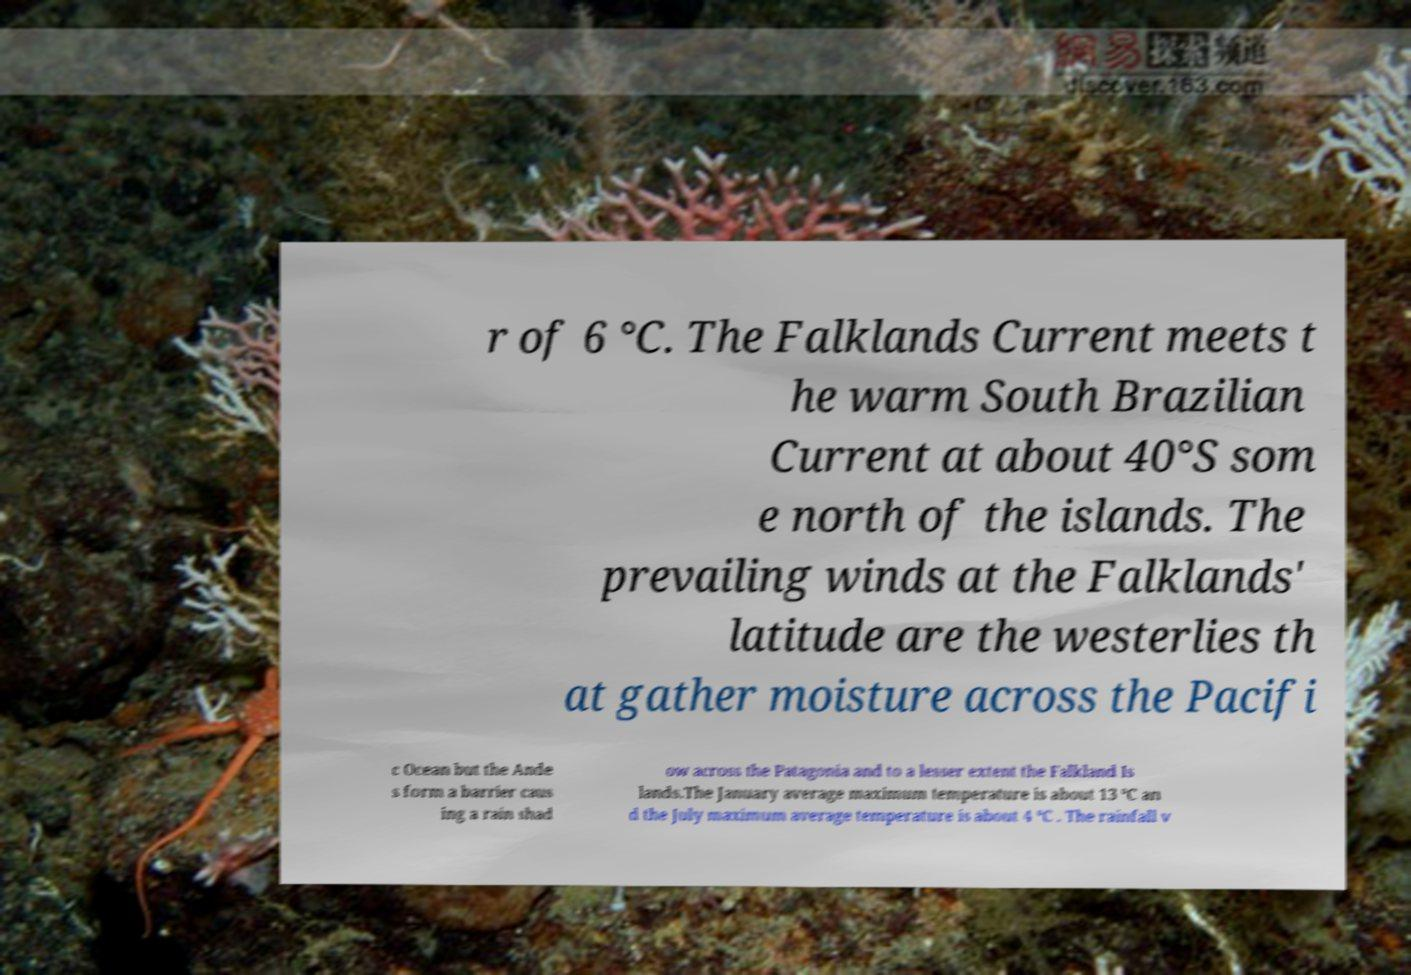Please identify and transcribe the text found in this image. r of 6 °C. The Falklands Current meets t he warm South Brazilian Current at about 40°S som e north of the islands. The prevailing winds at the Falklands' latitude are the westerlies th at gather moisture across the Pacifi c Ocean but the Ande s form a barrier caus ing a rain shad ow across the Patagonia and to a lesser extent the Falkland Is lands.The January average maximum temperature is about 13 °C an d the July maximum average temperature is about 4 °C . The rainfall v 